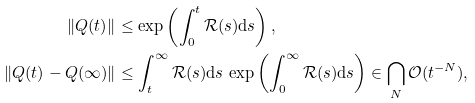<formula> <loc_0><loc_0><loc_500><loc_500>\| Q ( t ) \| & \leq \exp \left ( \int _ { 0 } ^ { t } \mathcal { R } ( s ) \mathrm d s \right ) , \\ \| Q ( t ) - Q ( \infty ) \| & \leq \int _ { t } ^ { \infty } \mathcal { R } ( s ) \mathrm d s \, \exp \left ( \int _ { 0 } ^ { \infty } \mathcal { R } ( s ) \mathrm d s \right ) \in \bigcap _ { N } \mathcal { O } ( t ^ { - N } ) ,</formula> 